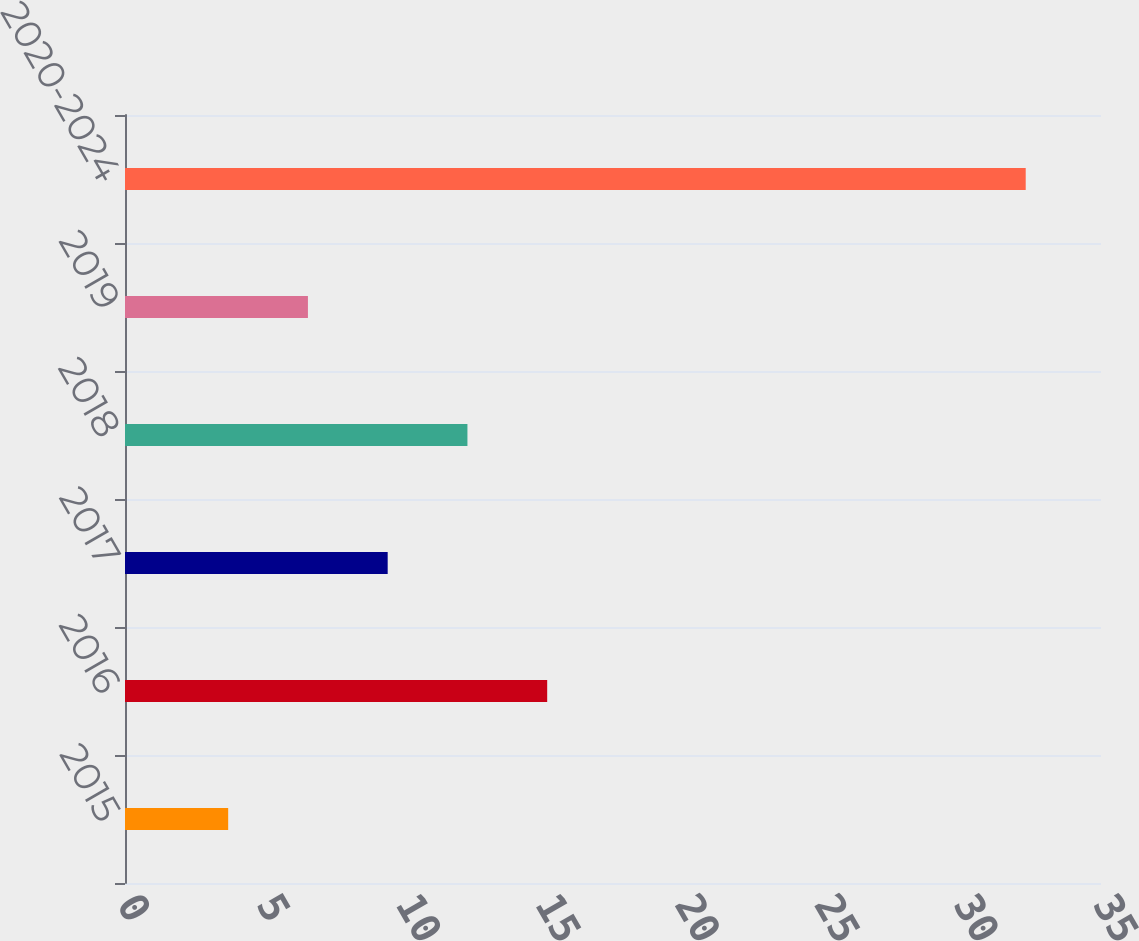<chart> <loc_0><loc_0><loc_500><loc_500><bar_chart><fcel>2015<fcel>2016<fcel>2017<fcel>2018<fcel>2019<fcel>2020-2024<nl><fcel>3.7<fcel>15.14<fcel>9.42<fcel>12.28<fcel>6.56<fcel>32.3<nl></chart> 